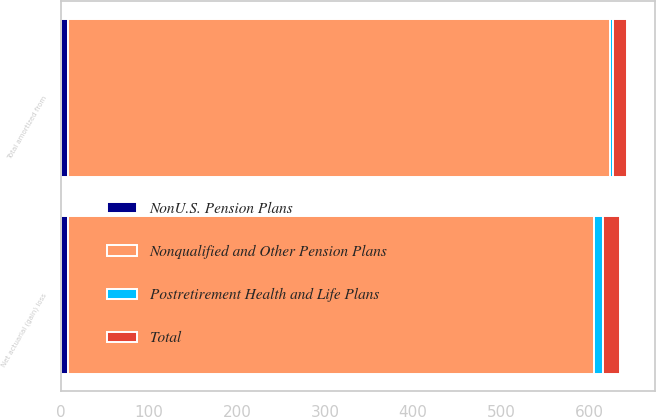Convert chart to OTSL. <chart><loc_0><loc_0><loc_500><loc_500><stacked_bar_chart><ecel><fcel>Net actuarial (gain) loss<fcel>Total amortized from<nl><fcel>Nonqualified and Other Pension Plans<fcel>598<fcel>616<nl><fcel>NonU.S. Pension Plans<fcel>8<fcel>8<nl><fcel>Postretirement Health and Life Plans<fcel>10<fcel>3<nl><fcel>Total<fcel>19<fcel>16<nl></chart> 